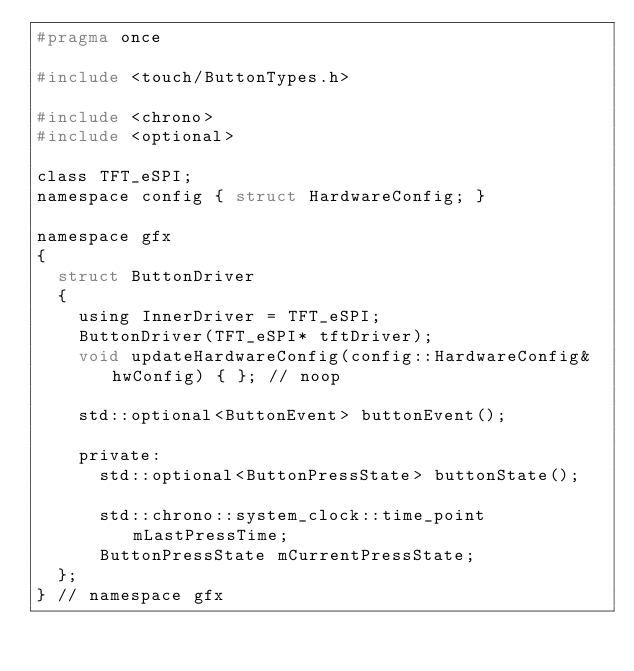Convert code to text. <code><loc_0><loc_0><loc_500><loc_500><_C_>#pragma once

#include <touch/ButtonTypes.h>

#include <chrono>
#include <optional>

class TFT_eSPI;
namespace config { struct HardwareConfig; }

namespace gfx
{
  struct ButtonDriver
  {
    using InnerDriver = TFT_eSPI;
    ButtonDriver(TFT_eSPI* tftDriver);
    void updateHardwareConfig(config::HardwareConfig& hwConfig) { }; // noop

    std::optional<ButtonEvent> buttonEvent();

    private:
      std::optional<ButtonPressState> buttonState();

      std::chrono::system_clock::time_point mLastPressTime;
      ButtonPressState mCurrentPressState;
  };
} // namespace gfx
</code> 